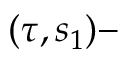Convert formula to latex. <formula><loc_0><loc_0><loc_500><loc_500>( \tau , s _ { 1 } ) -</formula> 